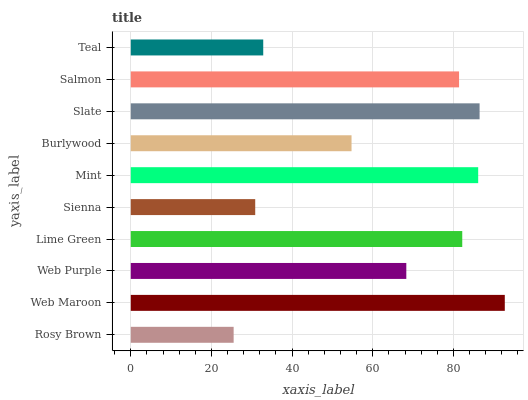Is Rosy Brown the minimum?
Answer yes or no. Yes. Is Web Maroon the maximum?
Answer yes or no. Yes. Is Web Purple the minimum?
Answer yes or no. No. Is Web Purple the maximum?
Answer yes or no. No. Is Web Maroon greater than Web Purple?
Answer yes or no. Yes. Is Web Purple less than Web Maroon?
Answer yes or no. Yes. Is Web Purple greater than Web Maroon?
Answer yes or no. No. Is Web Maroon less than Web Purple?
Answer yes or no. No. Is Salmon the high median?
Answer yes or no. Yes. Is Web Purple the low median?
Answer yes or no. Yes. Is Slate the high median?
Answer yes or no. No. Is Web Maroon the low median?
Answer yes or no. No. 